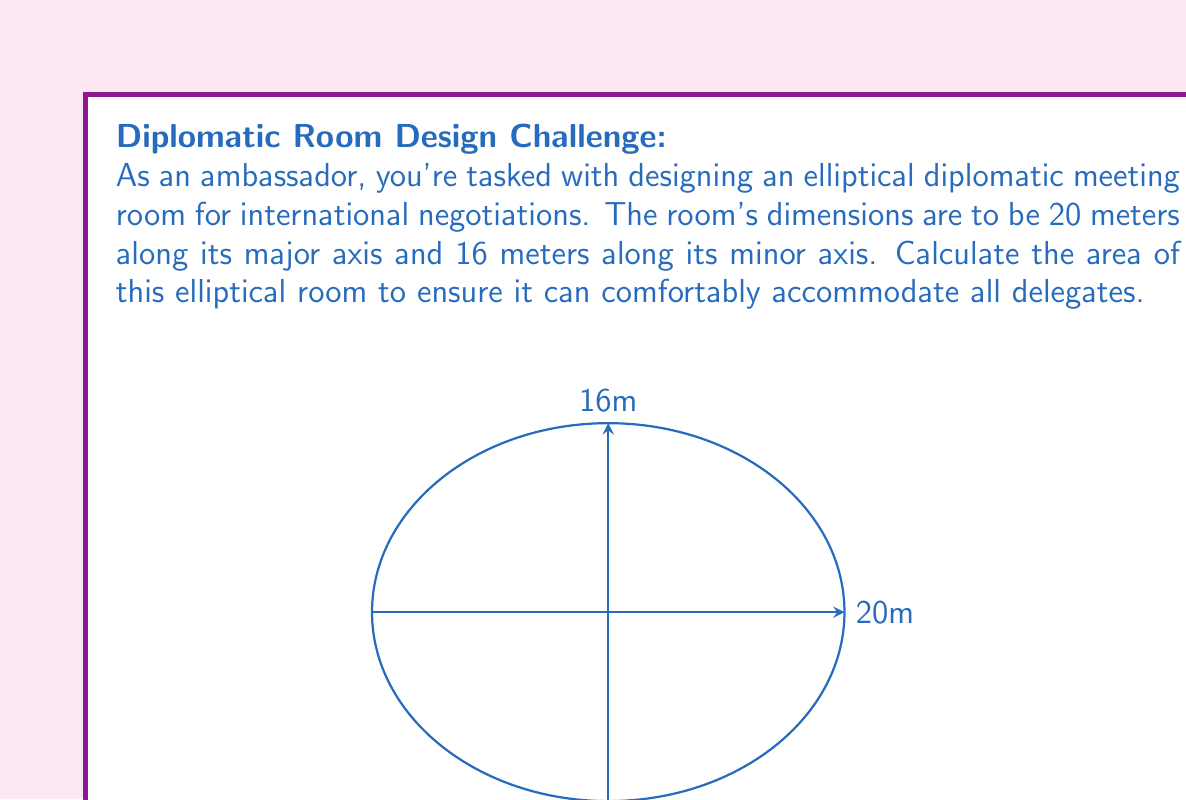Show me your answer to this math problem. To calculate the area of an ellipse, we use the formula:

$$A = \pi ab$$

Where:
$A$ is the area
$a$ is half the length of the major axis
$b$ is half the length of the minor axis

Given:
- Major axis = 20 meters
- Minor axis = 16 meters

Step 1: Determine $a$ and $b$
$a = 20 \div 2 = 10$ meters
$b = 16 \div 2 = 8$ meters

Step 2: Apply the formula
$$A = \pi ab$$
$$A = \pi (10)(8)$$

Step 3: Calculate
$$A = 80\pi$$

Step 4: Approximate (optional)
$$A \approx 251.33 \text{ square meters}$$

This area ensures ample space for diplomatic discussions and negotiations, accommodating delegates from various nations in a comfortable setting.
Answer: $80\pi$ square meters 